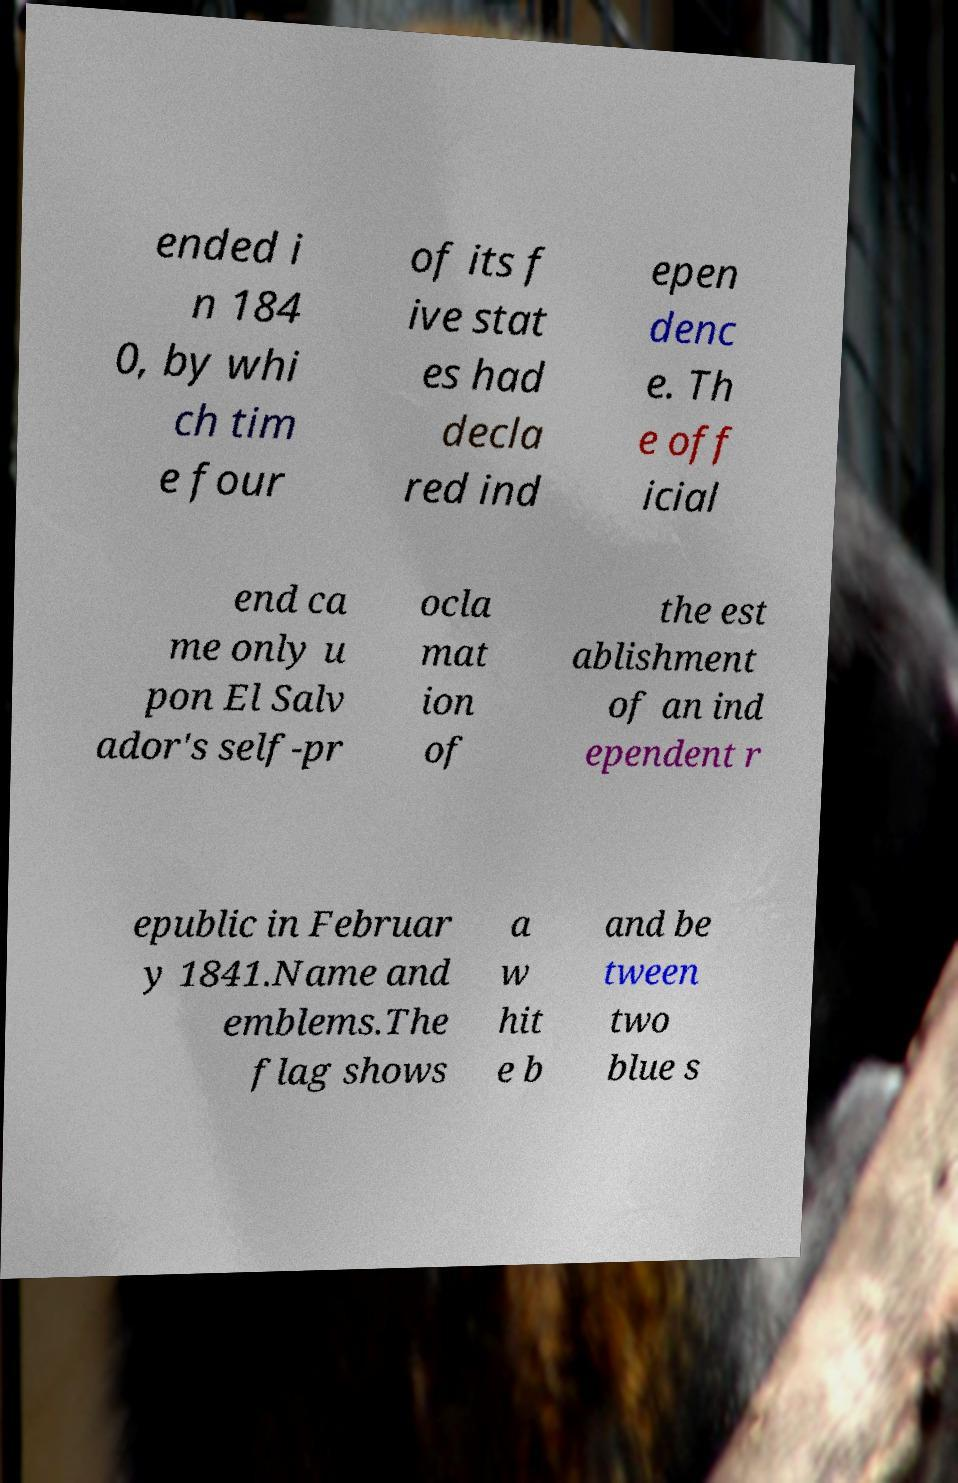I need the written content from this picture converted into text. Can you do that? ended i n 184 0, by whi ch tim e four of its f ive stat es had decla red ind epen denc e. Th e off icial end ca me only u pon El Salv ador's self-pr ocla mat ion of the est ablishment of an ind ependent r epublic in Februar y 1841.Name and emblems.The flag shows a w hit e b and be tween two blue s 